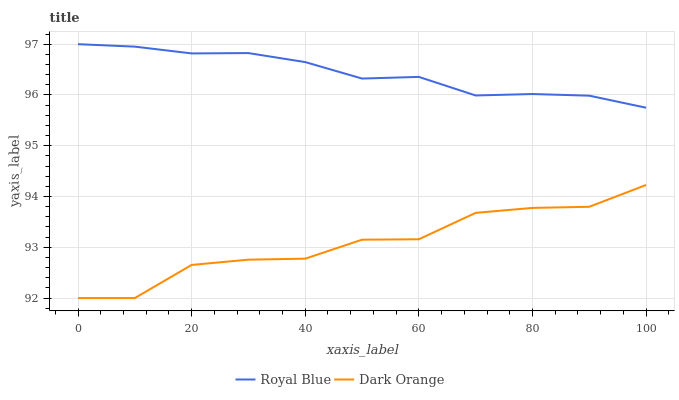Does Dark Orange have the maximum area under the curve?
Answer yes or no. No. Is Dark Orange the smoothest?
Answer yes or no. No. Does Dark Orange have the highest value?
Answer yes or no. No. Is Dark Orange less than Royal Blue?
Answer yes or no. Yes. Is Royal Blue greater than Dark Orange?
Answer yes or no. Yes. Does Dark Orange intersect Royal Blue?
Answer yes or no. No. 